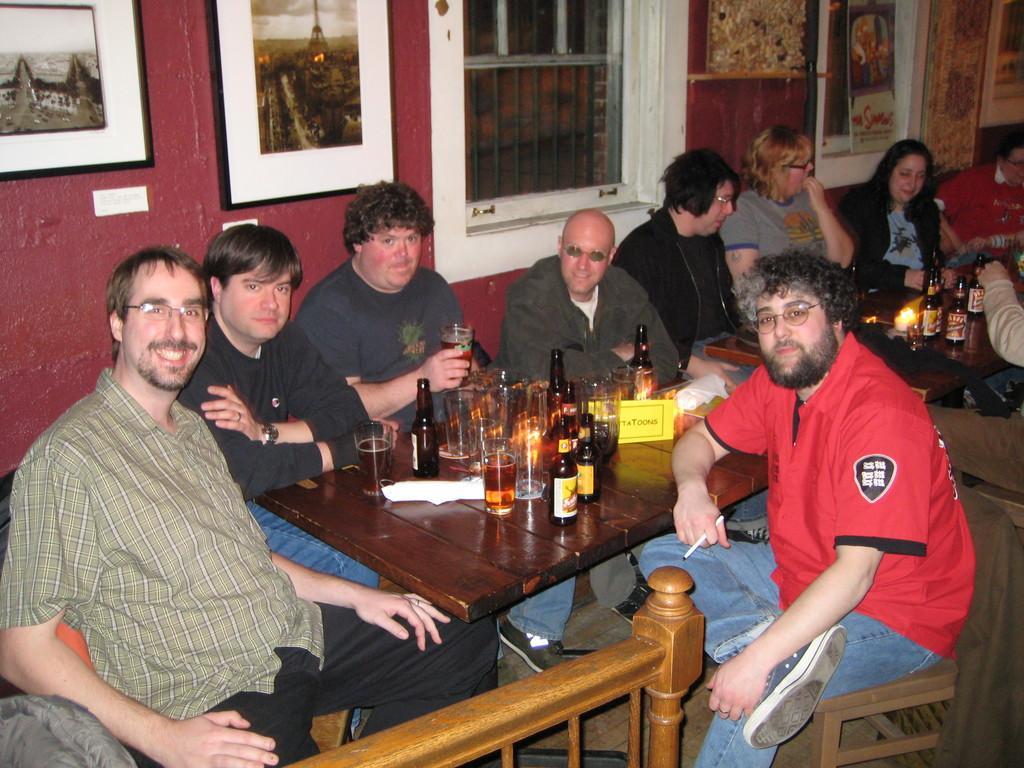Could you give a brief overview of what you see in this image? In the image we can see group of persons were sitting on the couch around the table and they were smiling. On table there is a wine bottles,glasses,tissue paper etc. in the background we can see wall,photo frames and window. 